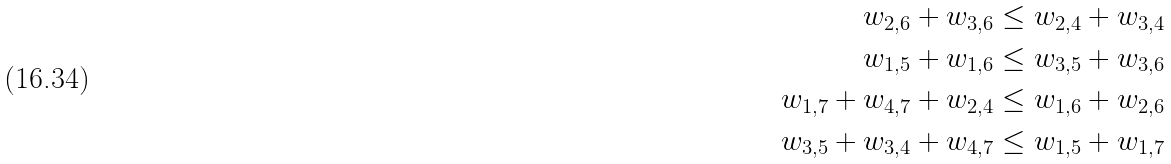Convert formula to latex. <formula><loc_0><loc_0><loc_500><loc_500>w _ { 2 , 6 } + w _ { 3 , 6 } & \leq w _ { 2 , 4 } + w _ { 3 , 4 } \\ w _ { 1 , 5 } + w _ { 1 , 6 } & \leq w _ { 3 , 5 } + w _ { 3 , 6 } \\ w _ { 1 , 7 } + w _ { 4 , 7 } + w _ { 2 , 4 } & \leq w _ { 1 , 6 } + w _ { 2 , 6 } \\ w _ { 3 , 5 } + w _ { 3 , 4 } + w _ { 4 , 7 } & \leq w _ { 1 , 5 } + w _ { 1 , 7 }</formula> 